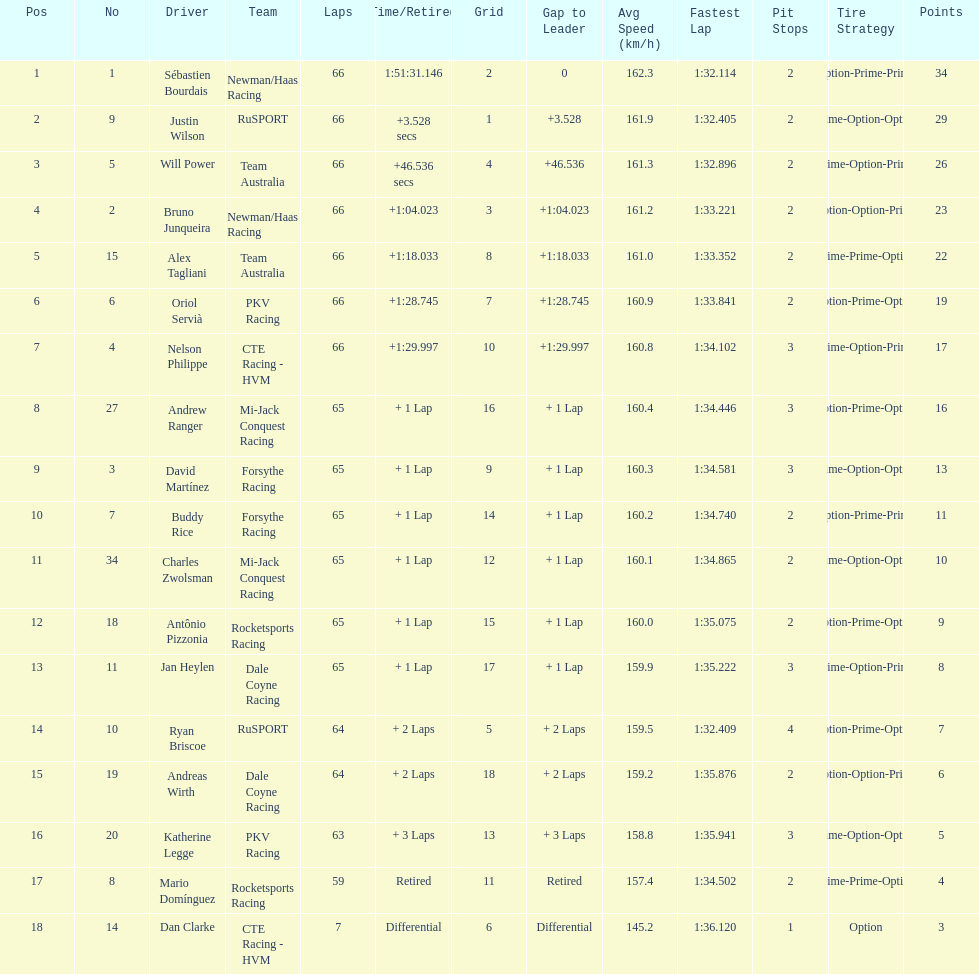Who finished directly after the driver who finished in 1:28.745? Nelson Philippe. 